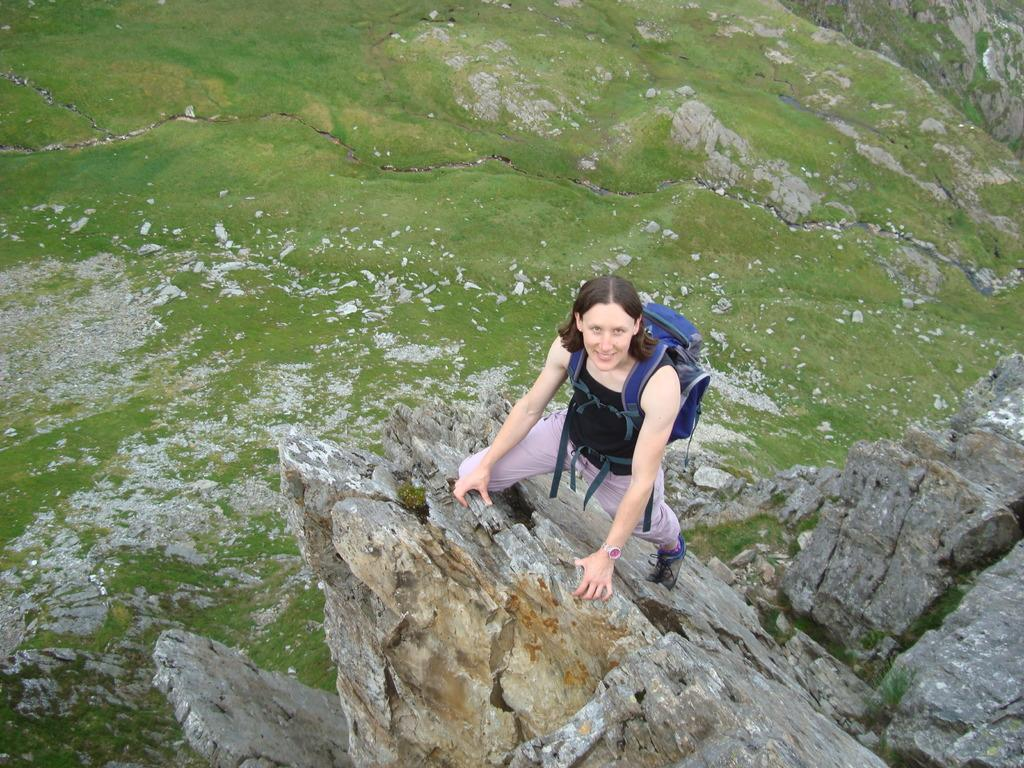Who is the main subject in the image? There is a woman in the image. What is the woman doing in the image? The woman is standing on a rock. What is the woman wearing in the image? The woman is wearing a bag. What type of natural environment is visible in the image? There is grass visible in the image. What type of news can be seen on the fish in the image? There are no fish or news present in the image; it features a woman standing on a rock with grass in the background. 